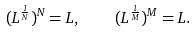<formula> <loc_0><loc_0><loc_500><loc_500>( L ^ { \frac { 1 } { N } } ) ^ { N } = L , \quad ( L ^ { \frac { 1 } { M } } ) ^ { M } = L .</formula> 